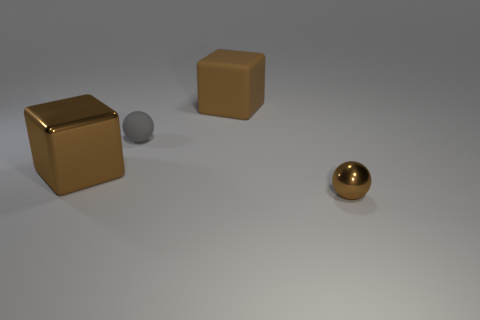Add 4 small metal spheres. How many objects exist? 8 Add 2 brown spheres. How many brown spheres are left? 3 Add 1 brown metallic things. How many brown metallic things exist? 3 Subtract 0 green balls. How many objects are left? 4 Subtract all tiny brown things. Subtract all tiny metallic objects. How many objects are left? 2 